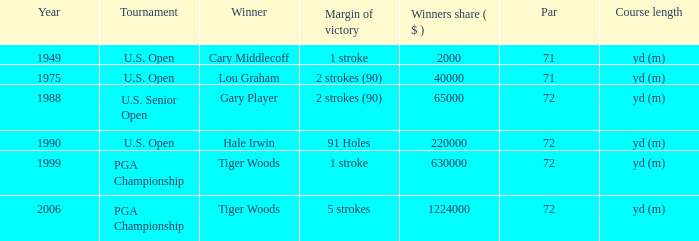When hale irwin is the winner what is the margin of victory? 91 Holes. Can you give me this table as a dict? {'header': ['Year', 'Tournament', 'Winner', 'Margin of victory', 'Winners share ( $ )', 'Par', 'Course length'], 'rows': [['1949', 'U.S. Open', 'Cary Middlecoff', '1 stroke', '2000', '71', 'yd (m)'], ['1975', 'U.S. Open', 'Lou Graham', '2 strokes (90)', '40000', '71', 'yd (m)'], ['1988', 'U.S. Senior Open', 'Gary Player', '2 strokes (90)', '65000', '72', 'yd (m)'], ['1990', 'U.S. Open', 'Hale Irwin', '91 Holes', '220000', '72', 'yd (m)'], ['1999', 'PGA Championship', 'Tiger Woods', '1 stroke', '630000', '72', 'yd (m)'], ['2006', 'PGA Championship', 'Tiger Woods', '5 strokes', '1224000', '72', 'yd (m)']]} 